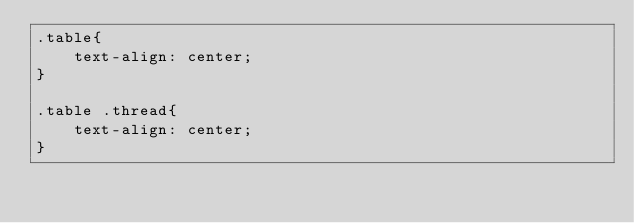Convert code to text. <code><loc_0><loc_0><loc_500><loc_500><_CSS_>.table{
    text-align: center;
}

.table .thread{
    text-align: center;
}</code> 